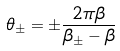<formula> <loc_0><loc_0><loc_500><loc_500>\theta _ { \pm } = \pm \frac { 2 \pi \beta } { \beta _ { \pm } - \beta }</formula> 